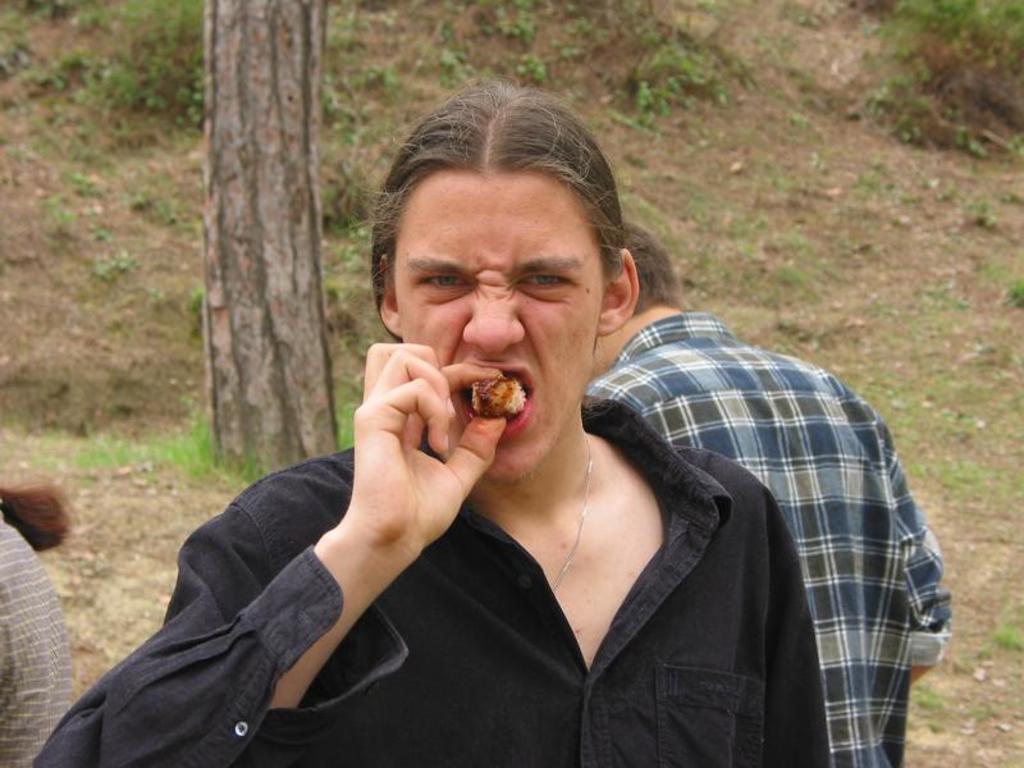Describe this image in one or two sentences. In this image there is a person eating a food item, in the background there are two persons standing and there is a grassland and a tree. 